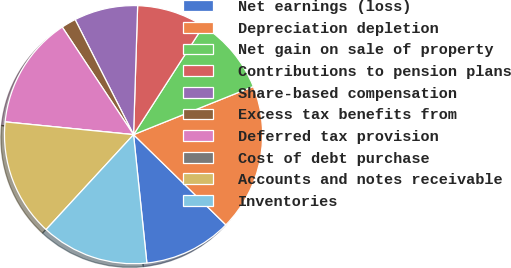<chart> <loc_0><loc_0><loc_500><loc_500><pie_chart><fcel>Net earnings (loss)<fcel>Depreciation depletion<fcel>Net gain on sale of property<fcel>Contributions to pension plans<fcel>Share-based compensation<fcel>Excess tax benefits from<fcel>Deferred tax provision<fcel>Cost of debt purchase<fcel>Accounts and notes receivable<fcel>Inventories<nl><fcel>11.04%<fcel>18.4%<fcel>9.82%<fcel>8.59%<fcel>7.98%<fcel>1.84%<fcel>14.11%<fcel>0.0%<fcel>14.72%<fcel>13.5%<nl></chart> 